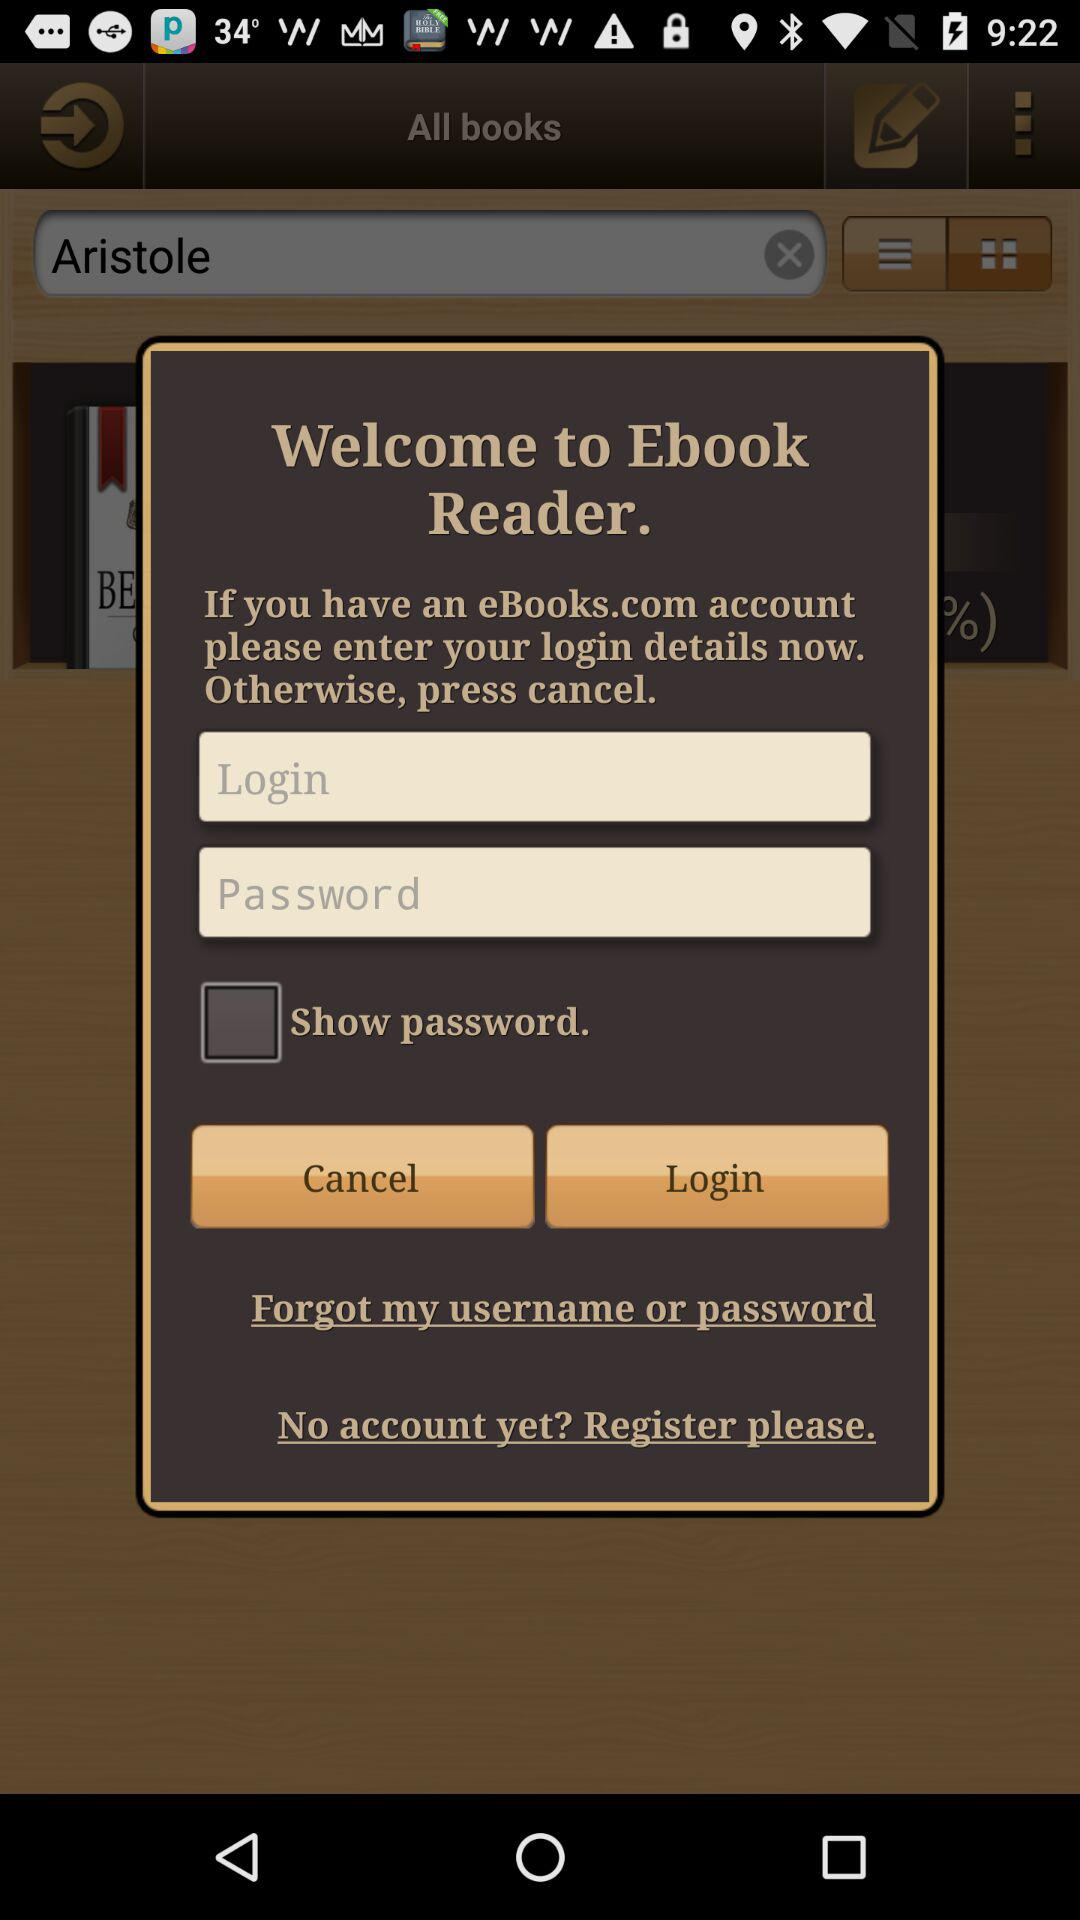What is the application name? The application name is "Ebook Reader". 